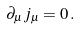<formula> <loc_0><loc_0><loc_500><loc_500>\partial _ { \mu } j _ { \mu } = 0 \, .</formula> 